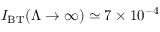Convert formula to latex. <formula><loc_0><loc_0><loc_500><loc_500>I _ { B T } ( \Lambda \to \infty ) \simeq 7 \times 1 0 ^ { - 4 }</formula> 